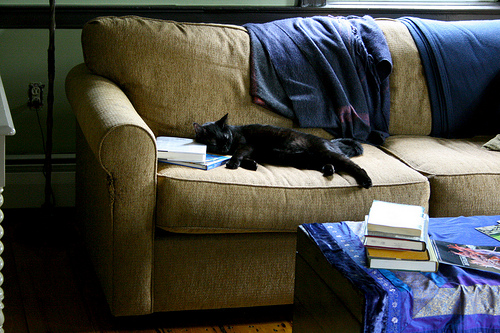<image>
Can you confirm if the cat is under the blanket? No. The cat is not positioned under the blanket. The vertical relationship between these objects is different. Is the cat above the couch? No. The cat is not positioned above the couch. The vertical arrangement shows a different relationship. 